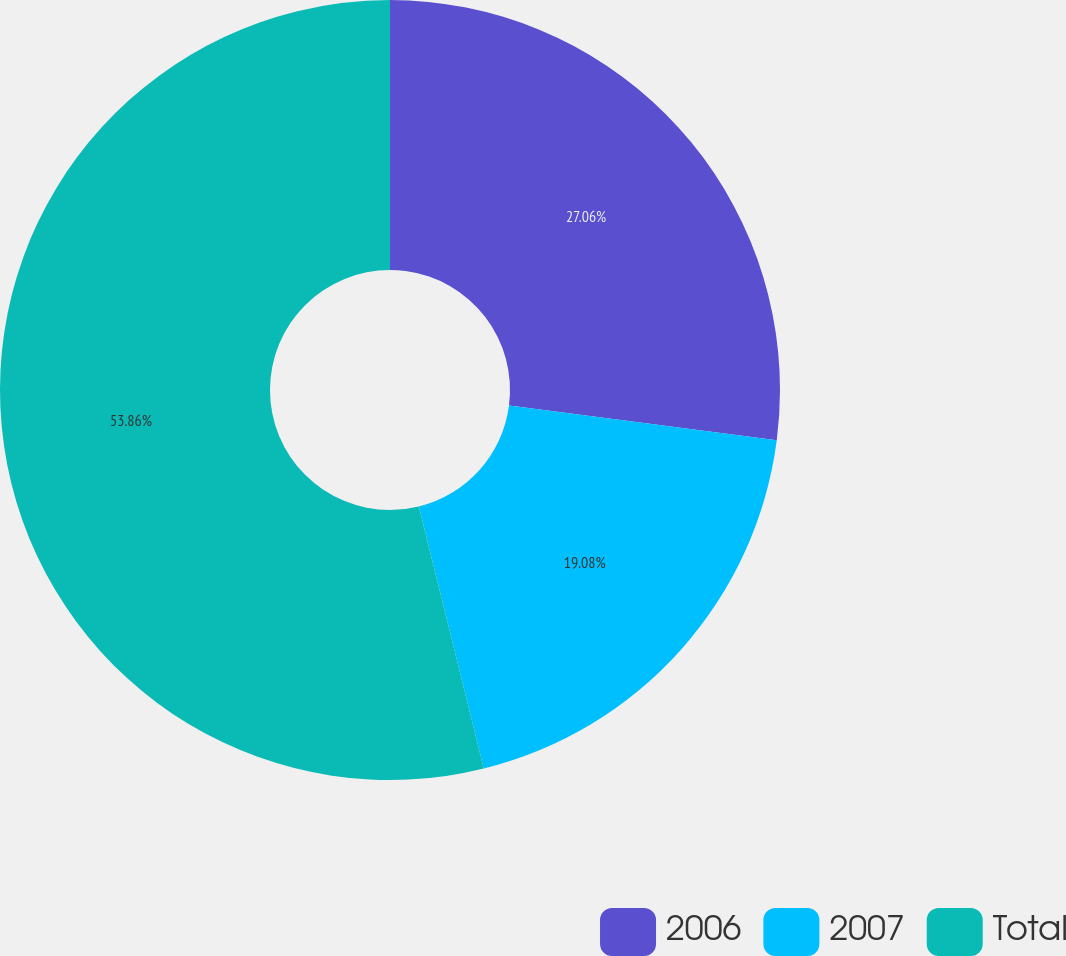<chart> <loc_0><loc_0><loc_500><loc_500><pie_chart><fcel>2006<fcel>2007<fcel>Total<nl><fcel>27.06%<fcel>19.08%<fcel>53.87%<nl></chart> 